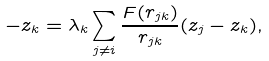<formula> <loc_0><loc_0><loc_500><loc_500>- z _ { k } = \lambda _ { k } \sum _ { j \neq i } \frac { F ( r _ { j k } ) } { r _ { j k } } ( z _ { j } - z _ { k } ) ,</formula> 